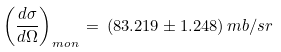<formula> <loc_0><loc_0><loc_500><loc_500>\left ( \frac { d \sigma } { d \Omega } \right ) _ { m o n } \, = \, ( 8 3 . 2 1 9 \pm 1 . 2 4 8 ) \, m b / s r</formula> 